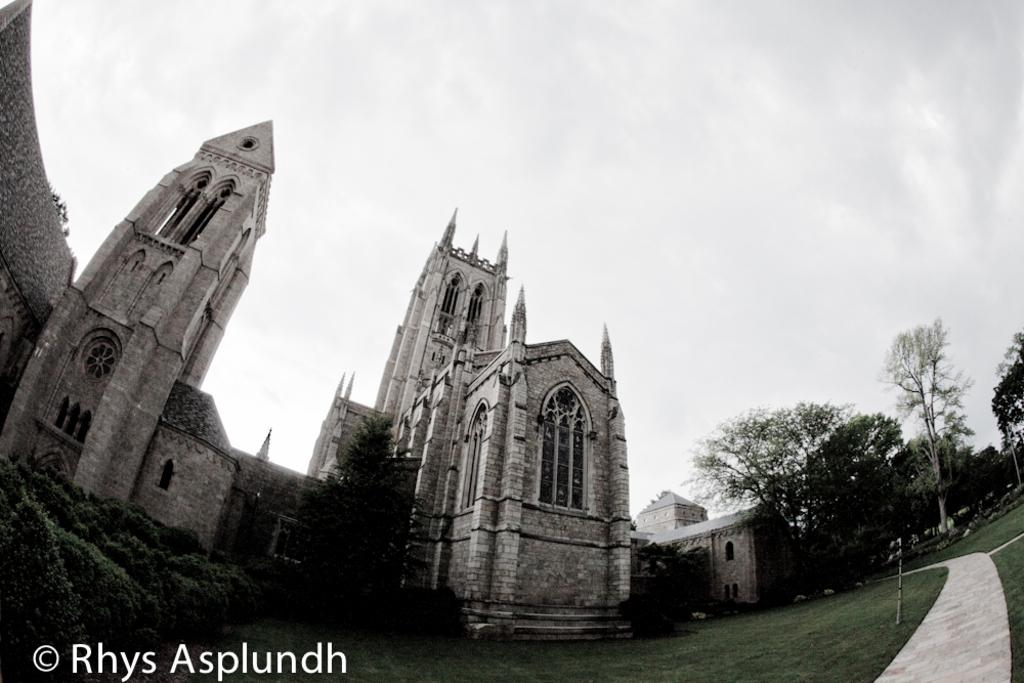What type of building is in the image? There is a cathedral in the image. What type of vegetation can be seen in the image? There are plants, trees, and grass in the image. What is visible at the top of the image? The sky is visible at the top of the image. What might be used for labeling or providing information in the image? There is some text on the image. How many girls are holding the jewel in the image? There are no girls or jewels present in the image. 